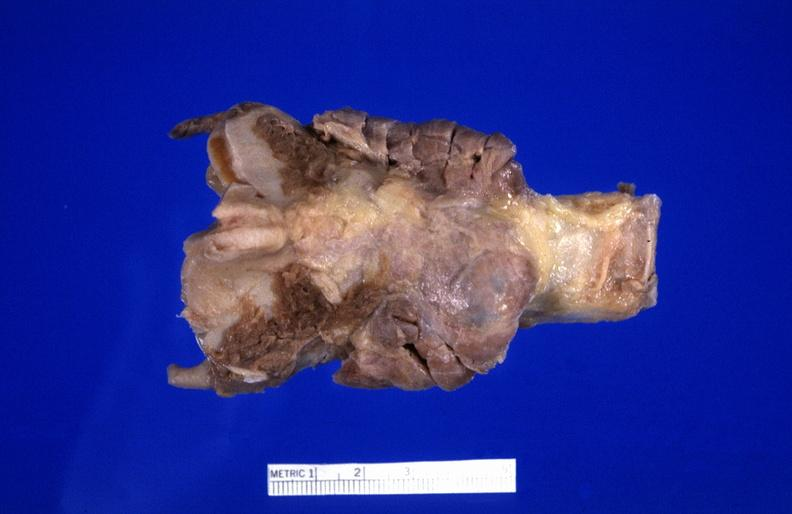s tuberculosis present?
Answer the question using a single word or phrase. No 